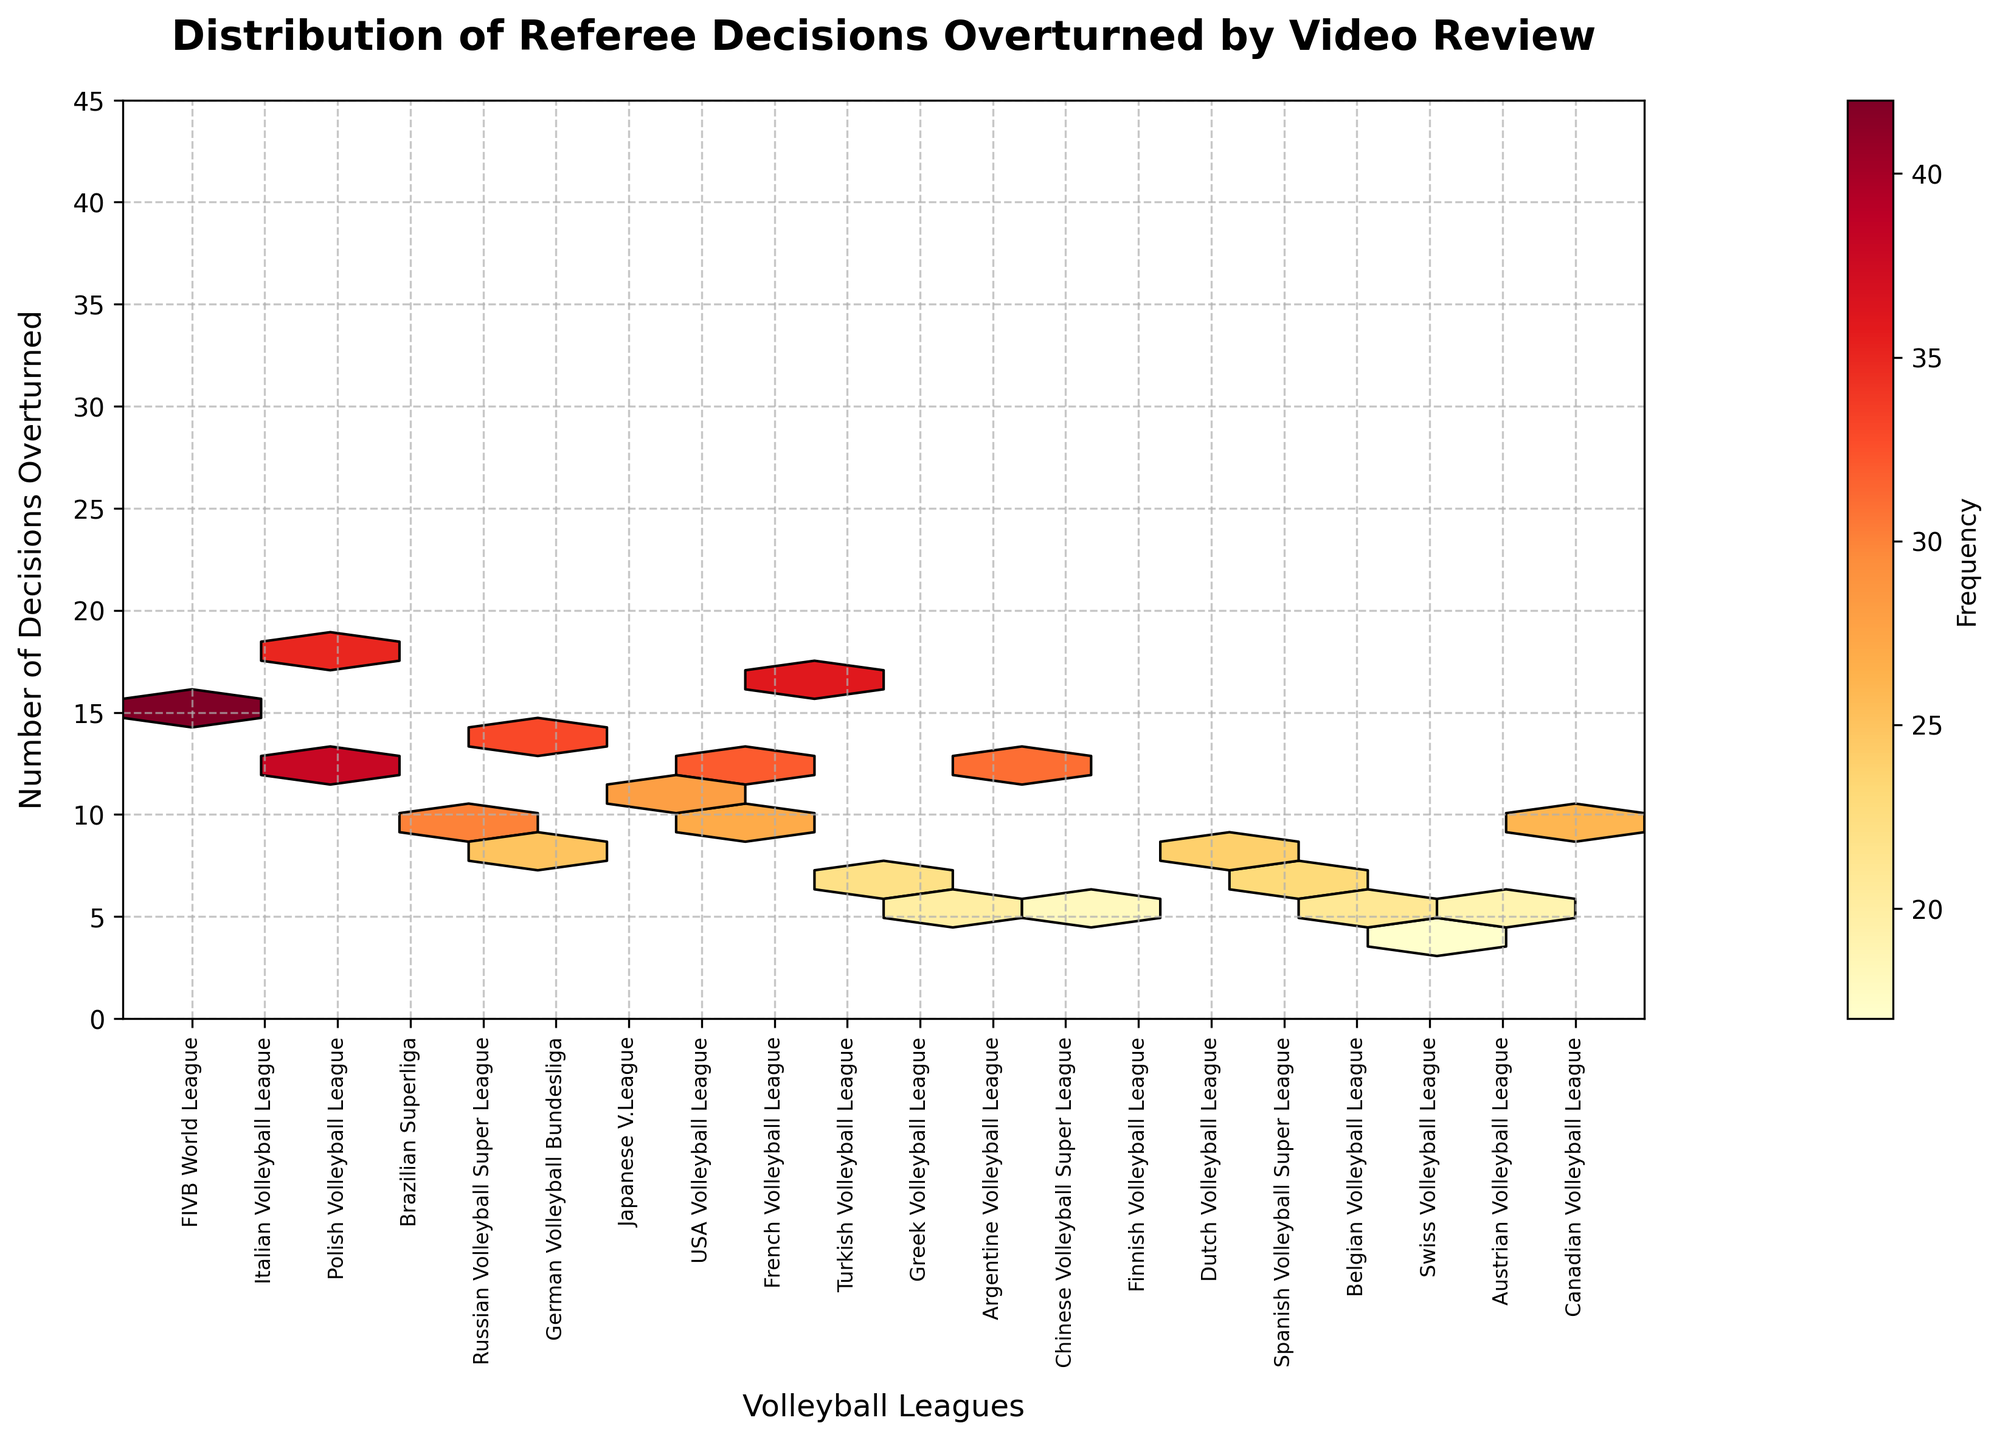Which volleyball league has the highest number of decisions overturned? By looking at the y-axis and the hexagons, the tallest peak is near the FIVB World League.
Answer: FIVB World League What is the range of overturned decisions across all leagues? The y-axis shows overturned decisions range from 15 to about 42.
Answer: 15 to 42 Which league has the second-highest frequency of overturned decisions? The color intensity and position suggest the Italian Volleyball League is second with slightly lower values than FIVB World League.
Answer: Italian Volleyball League What is the mean number of overturned decisions for the leagues shown? Sum the numbers on the y-axis for each league and divide by the number of leagues (20).
Answer: 27.8 Are any leagues close to the average number of overturned decisions? Compare each league's value with the average (27.8) derived.
Answer: Chinese Volleyball Super League, Brazilian Superliga Which leagues have fewer than 10 decisions overturned? Look for leagues plotted below the y-axis value of 10.
Answer: Finnish Volleyball League, Swiss Volleyball League, Austrian Volleyball League Are there more leagues with overturned decisions in the range of 25-35 or 35-45? Count the hexagons within the two ranges and compare.
Answer: 25-35 Do European leagues have a higher frequency of overturned decisions compared to non-European leagues? Compare collective frequencies between European leagues (e.g., German, Italian) and non-European ones (e.g., USA, Brazilian).
Answer: European leagues How does the frequency of overturned decisions in the Turkish Volleyball League compare with the Greek Volleyball League? Compare the y-values of Turkish (16) and Greek (7), observing that Turkish is higher.
Answer: Turkish Volleyball League What pattern do you observe for leagues with higher overturned decisions? Analyze that leagues with higher decisions seem clustered in colors indicating higher frequency around y-axis 30-40.
Answer: Higher overturned decisions are more frequent 